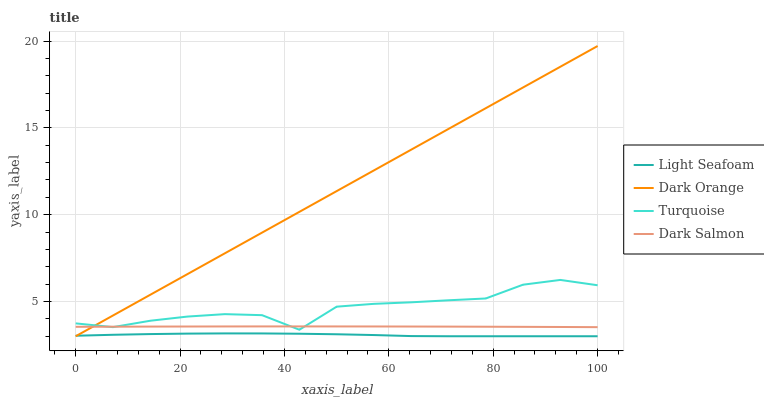Does Light Seafoam have the minimum area under the curve?
Answer yes or no. Yes. Does Dark Orange have the maximum area under the curve?
Answer yes or no. Yes. Does Turquoise have the minimum area under the curve?
Answer yes or no. No. Does Turquoise have the maximum area under the curve?
Answer yes or no. No. Is Dark Orange the smoothest?
Answer yes or no. Yes. Is Turquoise the roughest?
Answer yes or no. Yes. Is Light Seafoam the smoothest?
Answer yes or no. No. Is Light Seafoam the roughest?
Answer yes or no. No. Does Dark Orange have the lowest value?
Answer yes or no. Yes. Does Turquoise have the lowest value?
Answer yes or no. No. Does Dark Orange have the highest value?
Answer yes or no. Yes. Does Turquoise have the highest value?
Answer yes or no. No. Is Light Seafoam less than Turquoise?
Answer yes or no. Yes. Is Turquoise greater than Light Seafoam?
Answer yes or no. Yes. Does Dark Orange intersect Turquoise?
Answer yes or no. Yes. Is Dark Orange less than Turquoise?
Answer yes or no. No. Is Dark Orange greater than Turquoise?
Answer yes or no. No. Does Light Seafoam intersect Turquoise?
Answer yes or no. No. 